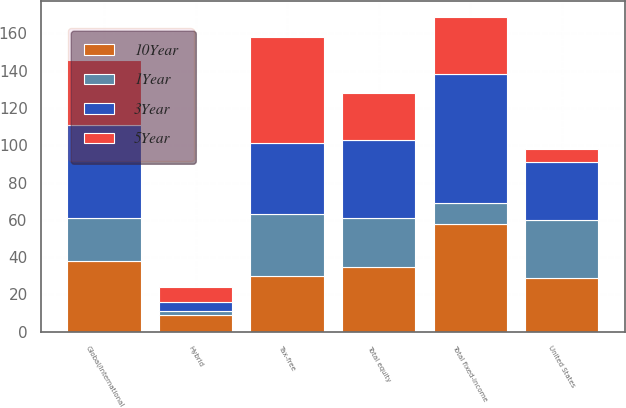Convert chart to OTSL. <chart><loc_0><loc_0><loc_500><loc_500><stacked_bar_chart><ecel><fcel>Global/international<fcel>United States<fcel>Total equity<fcel>Hybrid<fcel>Tax-free<fcel>Total fixed-income<nl><fcel>1Year<fcel>23<fcel>31<fcel>26<fcel>2<fcel>33<fcel>11<nl><fcel>10Year<fcel>38<fcel>29<fcel>35<fcel>9<fcel>30<fcel>58<nl><fcel>5Year<fcel>35<fcel>7<fcel>25<fcel>8<fcel>57<fcel>31<nl><fcel>3Year<fcel>50<fcel>31<fcel>42<fcel>5<fcel>38<fcel>69<nl></chart> 